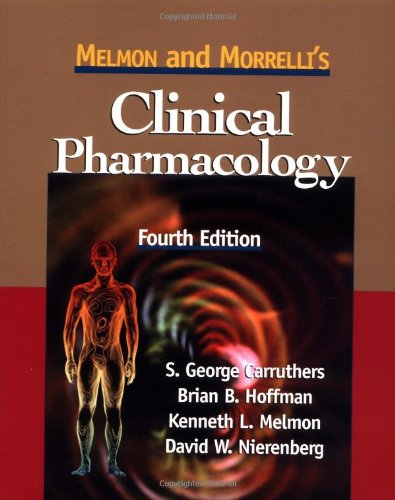Is this a pharmaceutical book? Yes, this book is predominantly focused on pharmaceuticals, providing insights into drug properties, uses, and interactions within a clinical context. 